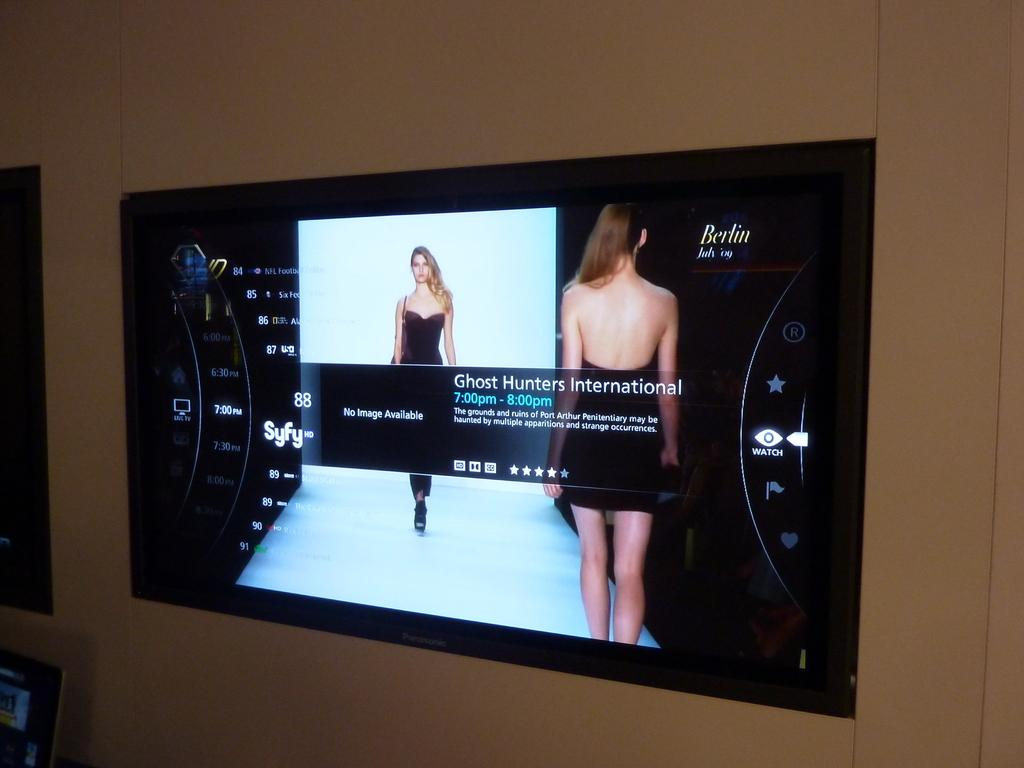<image>
Relay a brief, clear account of the picture shown. On a wall a monitor screen displays the words Ghost Hunters International. 